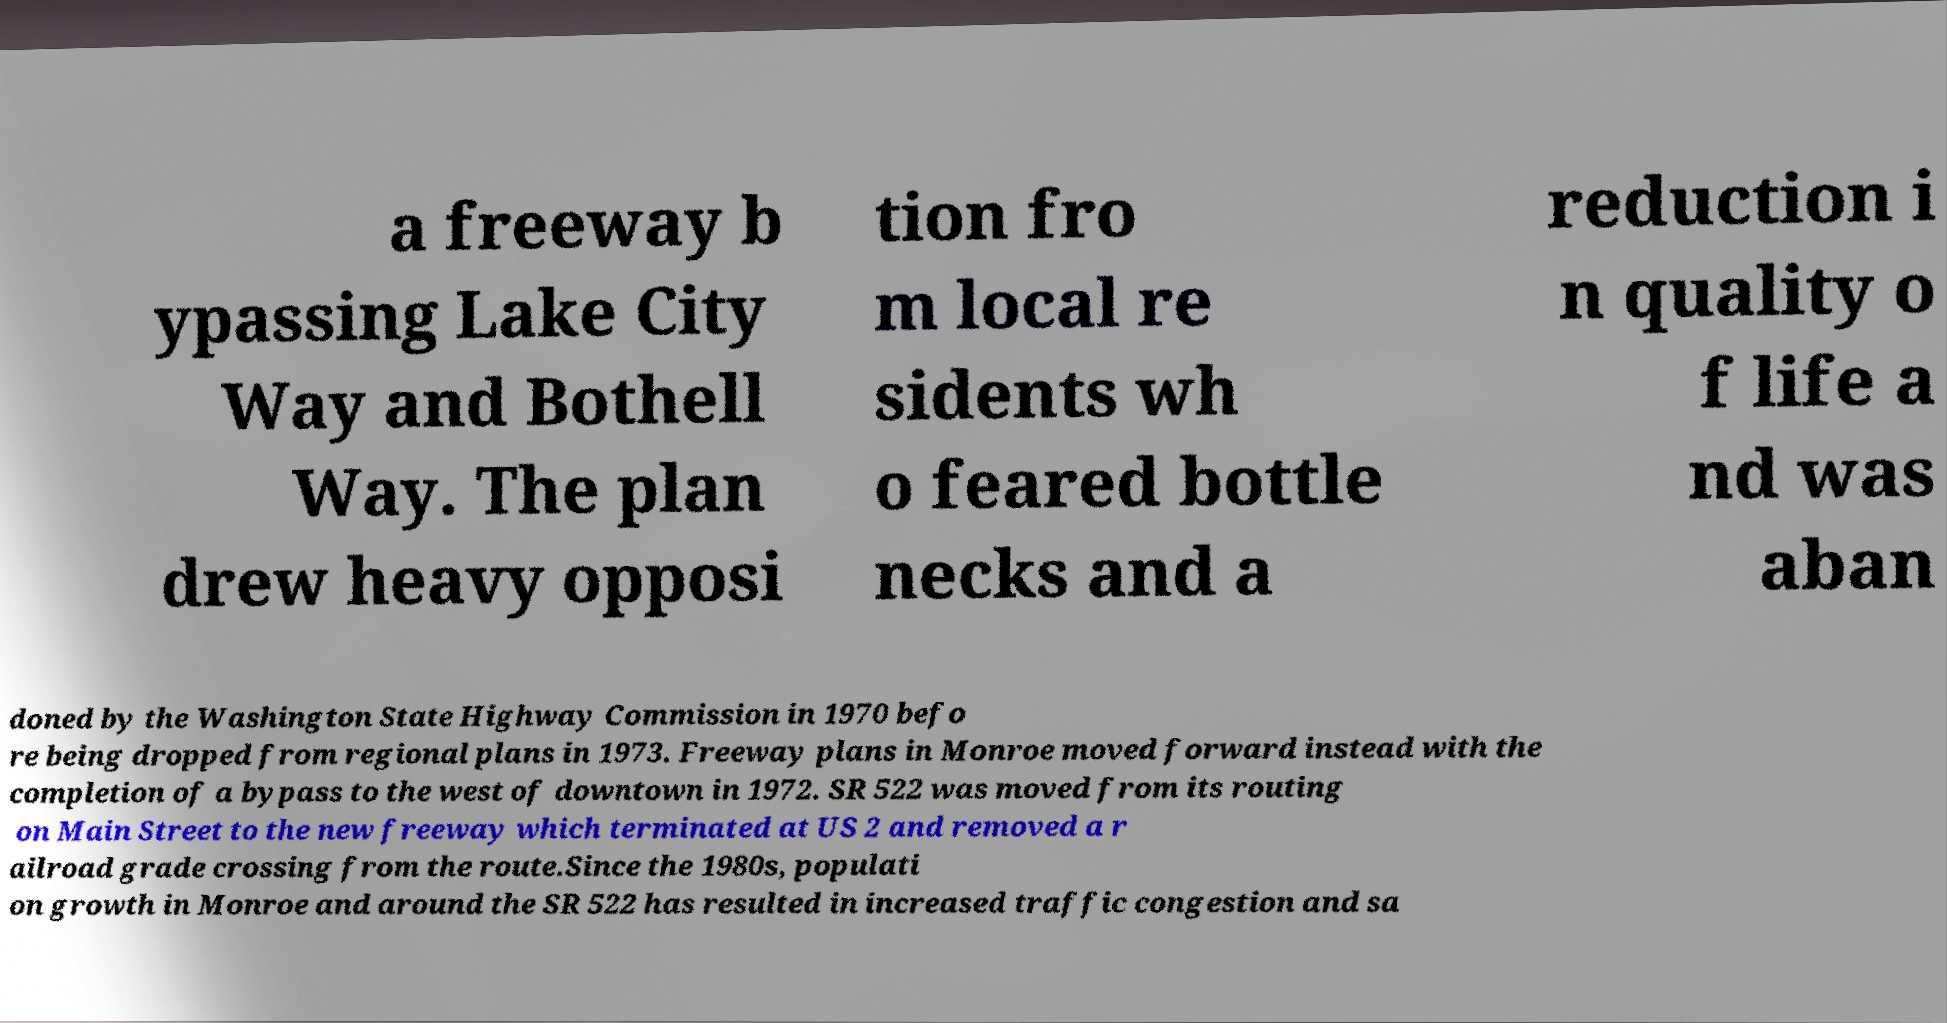Can you read and provide the text displayed in the image?This photo seems to have some interesting text. Can you extract and type it out for me? a freeway b ypassing Lake City Way and Bothell Way. The plan drew heavy opposi tion fro m local re sidents wh o feared bottle necks and a reduction i n quality o f life a nd was aban doned by the Washington State Highway Commission in 1970 befo re being dropped from regional plans in 1973. Freeway plans in Monroe moved forward instead with the completion of a bypass to the west of downtown in 1972. SR 522 was moved from its routing on Main Street to the new freeway which terminated at US 2 and removed a r ailroad grade crossing from the route.Since the 1980s, populati on growth in Monroe and around the SR 522 has resulted in increased traffic congestion and sa 